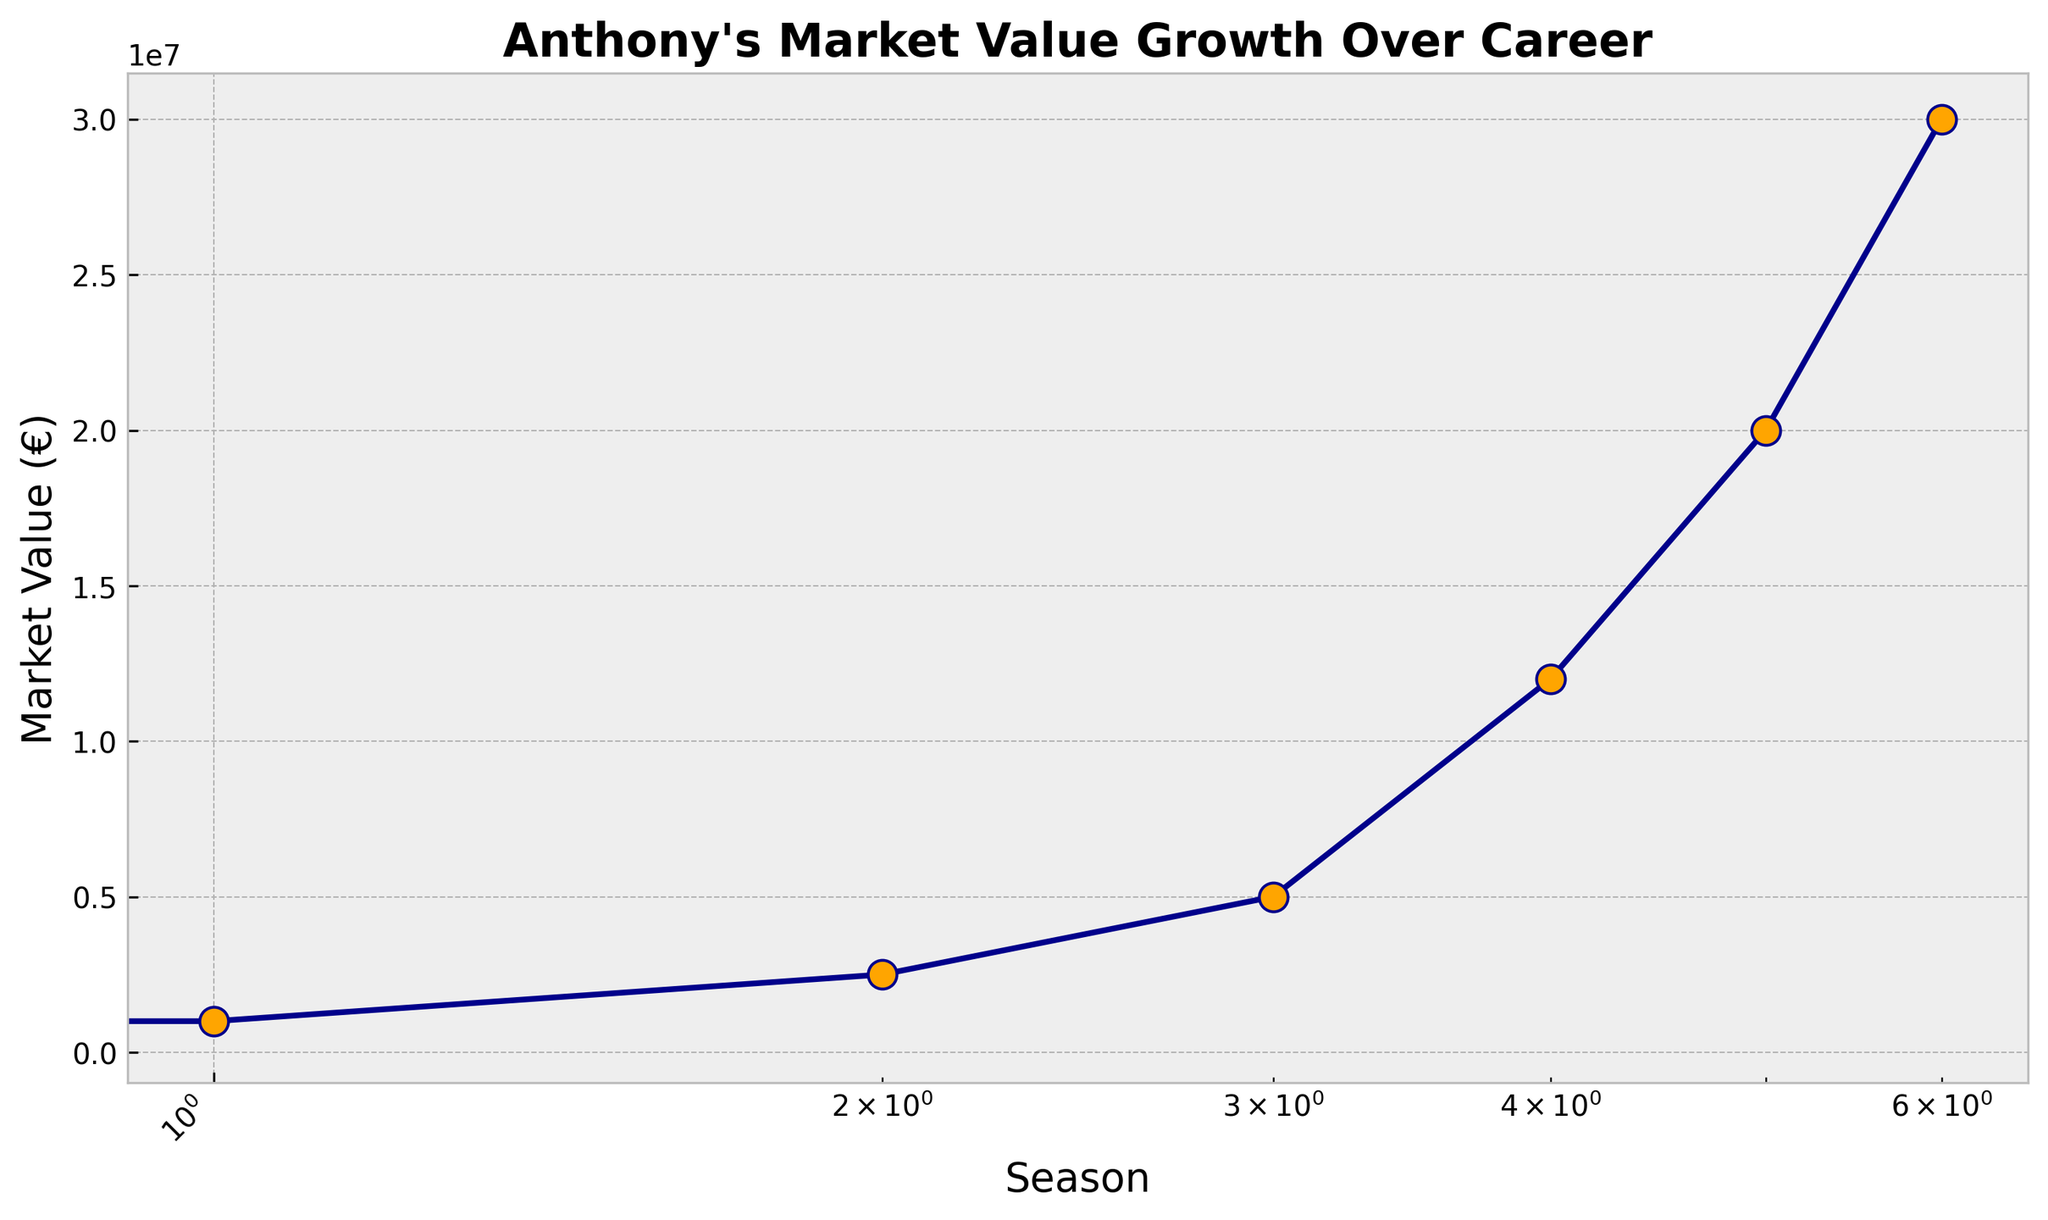Which season shows the highest increase in Anthony's market value compared to the previous season? To determine the highest increase, we calculate the difference between each consecutive season's market value. The biggest increase is between the 2021-2022 season (€12,000,000) and the 2020-2021 season (€5,000,000), which is €12,000,000 - €5,000,000 = €7,000,000.
Answer: 2021-2022 How many times did Anthony's market value double or more from one season to the next? We need to compare the market value of each season with the previous one to check if it doubled (or more than doubled) each time. Between 2017-2018 (€500,000) and 2018-2019 (€1,000,000), it doubled. Between 2018-2019 (€1,000,000) and 2019-2020 (€2,500,000), it more than doubled. Between 2019-2020 (€2,500,000) and 2020-2021 (€5,000,000), it doubled. Other jumps do not double. So, it doubled or more 3 times.
Answer: 3 When did Anthony's market value reach 20 million euros? By looking at the plot, Anthony's market value reached 20 million euros during the 2022-2023 season.
Answer: 2022-2023 What is the median market value over the years shown? To find the median, we list the values in ascending order: €500,000, €1,000,000, €2,500,000, €5,000,000, €12,000,000, €20,000,000, €30,000,000. The median value is the middle value, which is the 4th value, €5,000,000.
Answer: €5,000,000 How does the market value in 2020-2021 compare to that in 2017-2018? To compare the market values, we take 2020-2021 (€5,000,000) and compare it to 2017-2018 (€500,000). The market value in 2020-2021 is 10 times greater than in 2017-2018.
Answer: 10 times greater What is the average annual increase in market value from 2017-2018 to 2023-2024? To compute the average increase, we take the total increase and divide by the number of seasons. The total increase is €30,000,000 - €500,000 = €29,500,000. There are 6 intervals between 7 seasons. So, the average annual increase is €29,500,000 / 6 = €4,916,666.67.
Answer: €4,916,666.67 Which season had the smallest increase in market value compared to the previous season? We calculate the increase for each season and find that the smallest increase is between the 2018-2019 season (€1,000,000) and 2017-2018 (€500,000), which is €1,000,000 - €500,000 = €500,000.
Answer: 2018-2019 What is the cumulative market value by the 2023-2024 season? The cumulative market value is the sum of all annual market values from 2017-2018 to 2023-2024: €500,000 + €1,000,000 + €2,500,000 + €5,000,000 + €12,000,000 + €20,000,000 + €30,000,000 = €71,000,000.
Answer: €71,000,000 Considering the visual attributes, what is the marker color used to represent each season's market value on the plot? According to the provided code, the color of the markers on the plot is orange.
Answer: Orange What is the general trend of Anthony's market value over his career based on the plot? By observing the plot, we can see that Anthony's market value has been consistently increasing each season, indicating an overall positive trend.
Answer: Increasing 